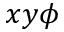<formula> <loc_0><loc_0><loc_500><loc_500>x y \phi</formula> 